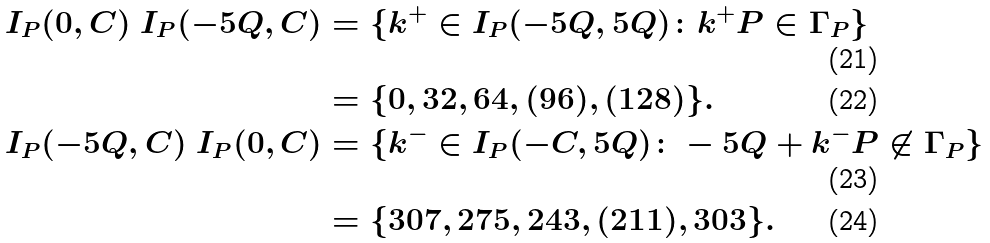Convert formula to latex. <formula><loc_0><loc_0><loc_500><loc_500>I _ { P } ( 0 , C ) \ I _ { P } ( - 5 Q , C ) & = \{ k ^ { + } \in I _ { P } ( - 5 Q , 5 Q ) \colon k ^ { + } P \in \Gamma _ { P } \} \\ & = \{ 0 , 3 2 , 6 4 , ( 9 6 ) , ( 1 2 8 ) \} . \\ I _ { P } ( - 5 Q , C ) \ I _ { P } ( 0 , C ) & = \{ k ^ { - } \in I _ { P } ( - C , 5 Q ) \colon - 5 Q + k ^ { - } P \not \in \Gamma _ { P } \} \\ & = \{ 3 0 7 , 2 7 5 , 2 4 3 , ( 2 1 1 ) , 3 0 3 \} .</formula> 